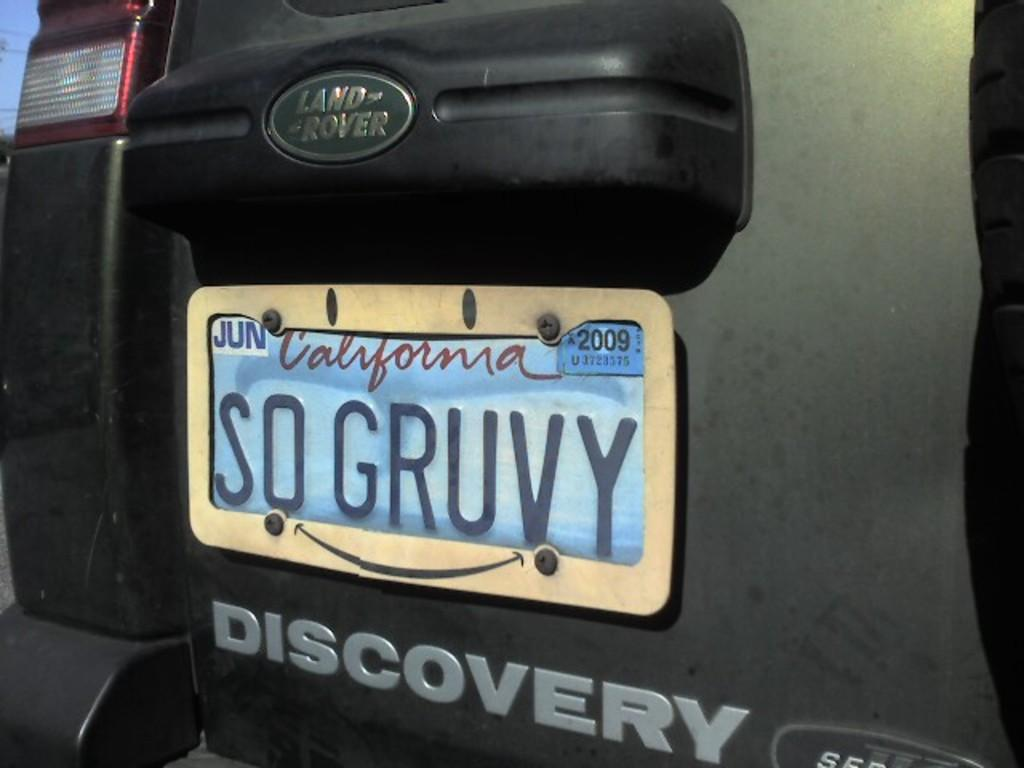Provide a one-sentence caption for the provided image. A Land Rover has a SO GRUVY vanity plate. 